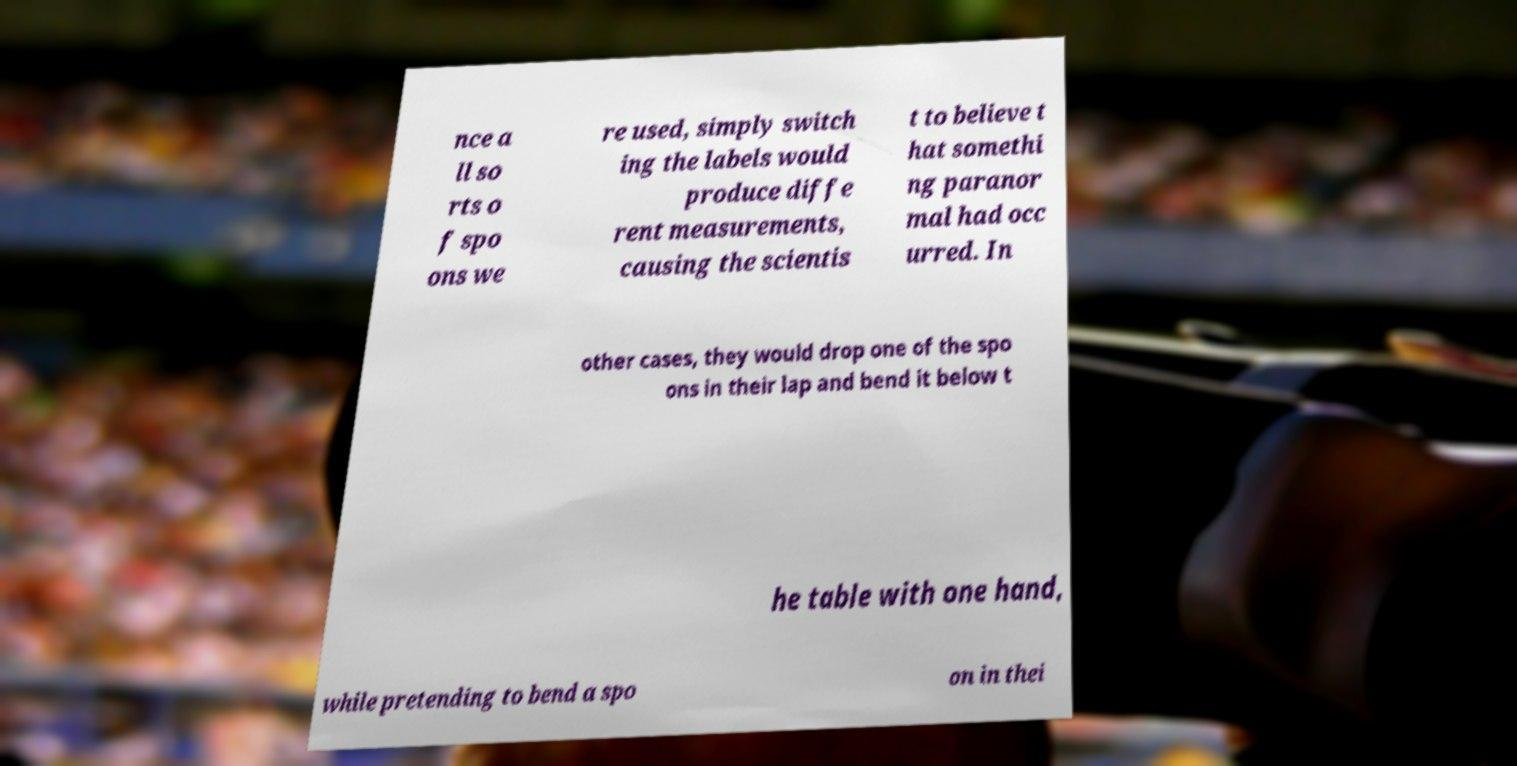Please read and relay the text visible in this image. What does it say? nce a ll so rts o f spo ons we re used, simply switch ing the labels would produce diffe rent measurements, causing the scientis t to believe t hat somethi ng paranor mal had occ urred. In other cases, they would drop one of the spo ons in their lap and bend it below t he table with one hand, while pretending to bend a spo on in thei 